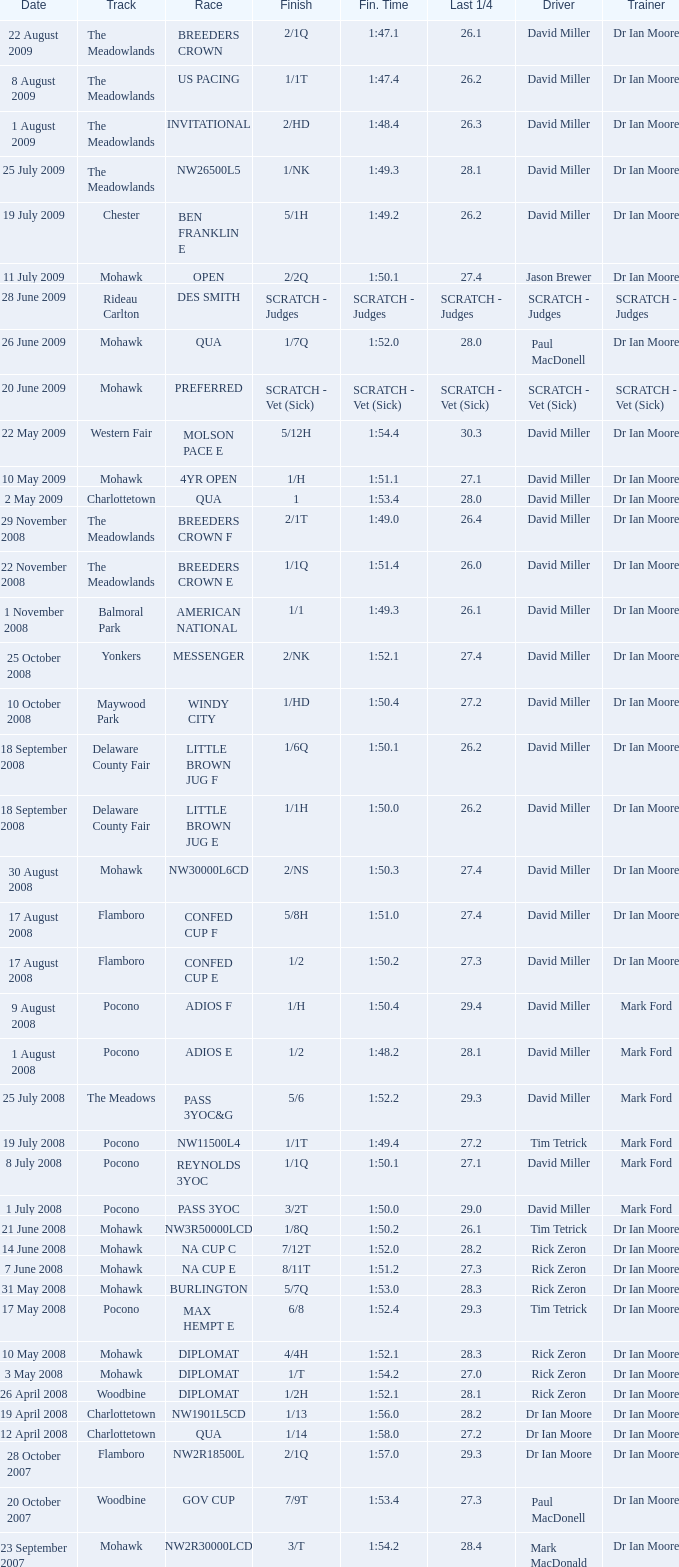For a qua race with a 2:03.1 finishing time, what is the last quarter's duration? 29.2. 